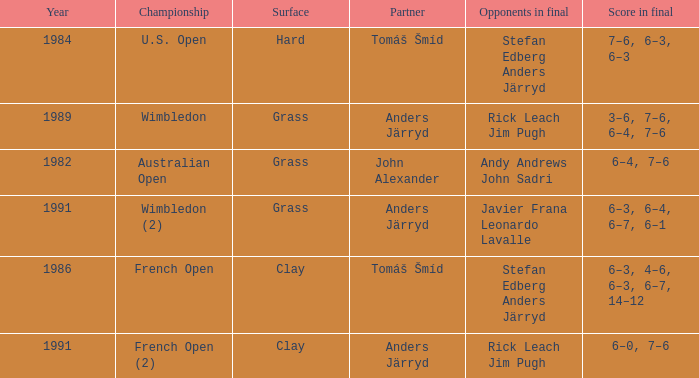What was the final score in 1986? 6–3, 4–6, 6–3, 6–7, 14–12. 